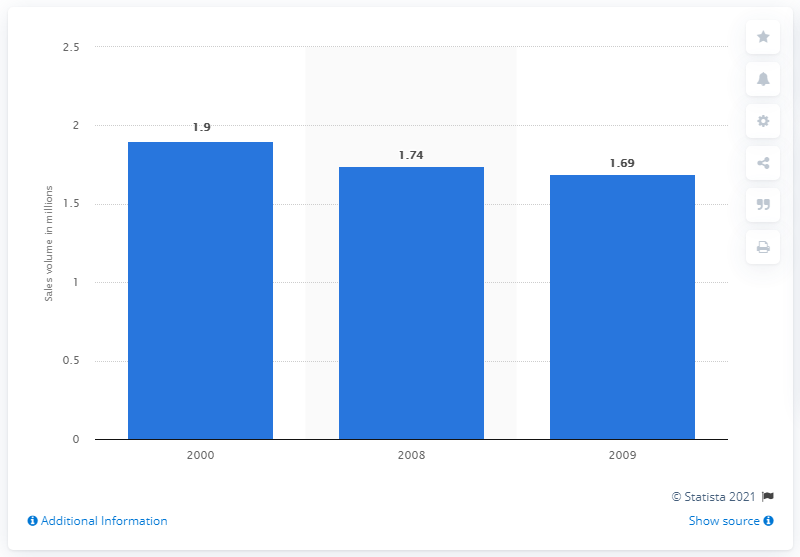Specify some key components in this picture. According to data from 2000, approximately 1.9 caskets were sold in the United States. 